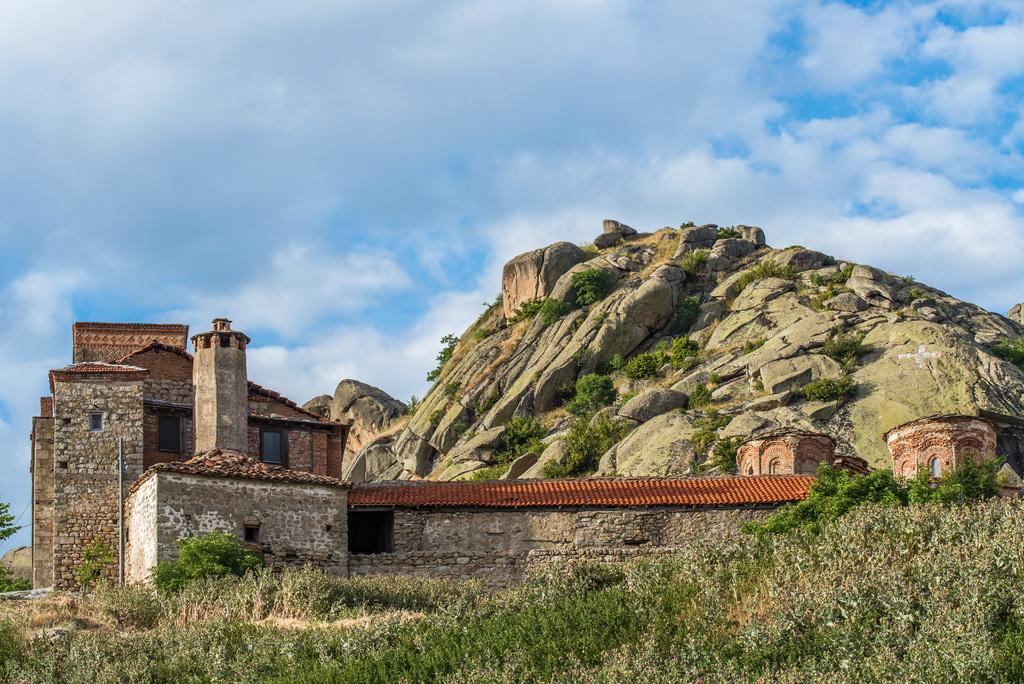What type of structure is visible in the image? There is a building with windows in the image. What natural feature can be seen in the image? There is a hill with rocks in the image. What type of vegetation is present in the image? Trees and plants are visible in the image. What can be seen in the sky in the image? Clouds are in the sky in the image. What type of steel structure is visible in the image? There is no steel structure present in the image. What is the source of the smoke in the image? There is no smoke present in the image. 